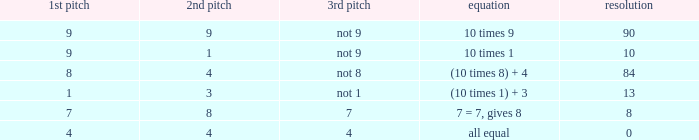I'm looking to parse the entire table for insights. Could you assist me with that? {'header': ['1st pitch', '2nd pitch', '3rd pitch', 'equation', 'resolution'], 'rows': [['9', '9', 'not 9', '10 times 9', '90'], ['9', '1', 'not 9', '10 times 1', '10'], ['8', '4', 'not 8', '(10 times 8) + 4', '84'], ['1', '3', 'not 1', '(10 times 1) + 3', '13'], ['7', '8', '7', '7 = 7, gives 8', '8'], ['4', '4', '4', 'all equal', '0']]} What is the equation where the 3rd throw is 7? 7 = 7, gives 8. 